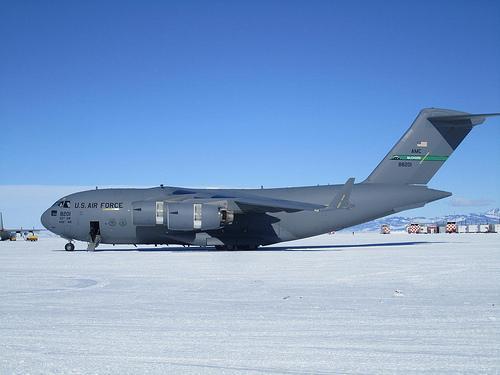How many wings are visible?
Give a very brief answer. 1. 